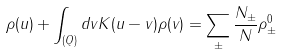Convert formula to latex. <formula><loc_0><loc_0><loc_500><loc_500>\rho ( u ) + \int _ { ( Q ) } d v K ( u - v ) \rho ( v ) = \sum _ { \pm } { \frac { N _ { \pm } } { N } } \rho _ { \pm } ^ { 0 }</formula> 